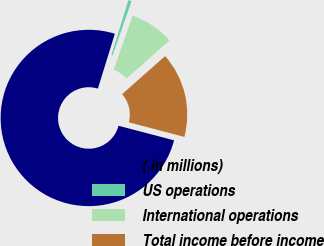<chart> <loc_0><loc_0><loc_500><loc_500><pie_chart><fcel>( in millions)<fcel>US operations<fcel>International operations<fcel>Total income before income<nl><fcel>75.69%<fcel>0.59%<fcel>8.1%<fcel>15.61%<nl></chart> 